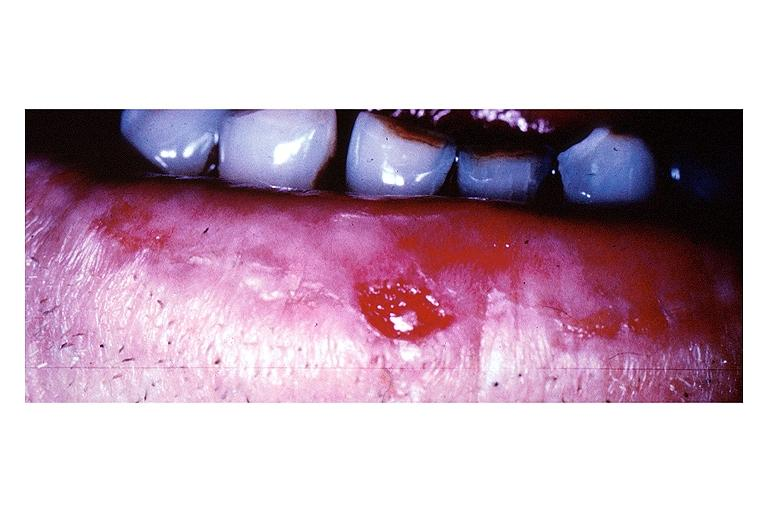where is this?
Answer the question using a single word or phrase. Oral 